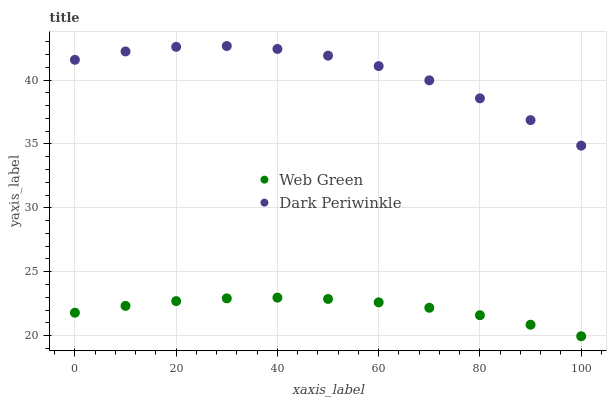Does Web Green have the minimum area under the curve?
Answer yes or no. Yes. Does Dark Periwinkle have the maximum area under the curve?
Answer yes or no. Yes. Does Web Green have the maximum area under the curve?
Answer yes or no. No. Is Web Green the smoothest?
Answer yes or no. Yes. Is Dark Periwinkle the roughest?
Answer yes or no. Yes. Is Web Green the roughest?
Answer yes or no. No. Does Web Green have the lowest value?
Answer yes or no. Yes. Does Dark Periwinkle have the highest value?
Answer yes or no. Yes. Does Web Green have the highest value?
Answer yes or no. No. Is Web Green less than Dark Periwinkle?
Answer yes or no. Yes. Is Dark Periwinkle greater than Web Green?
Answer yes or no. Yes. Does Web Green intersect Dark Periwinkle?
Answer yes or no. No. 